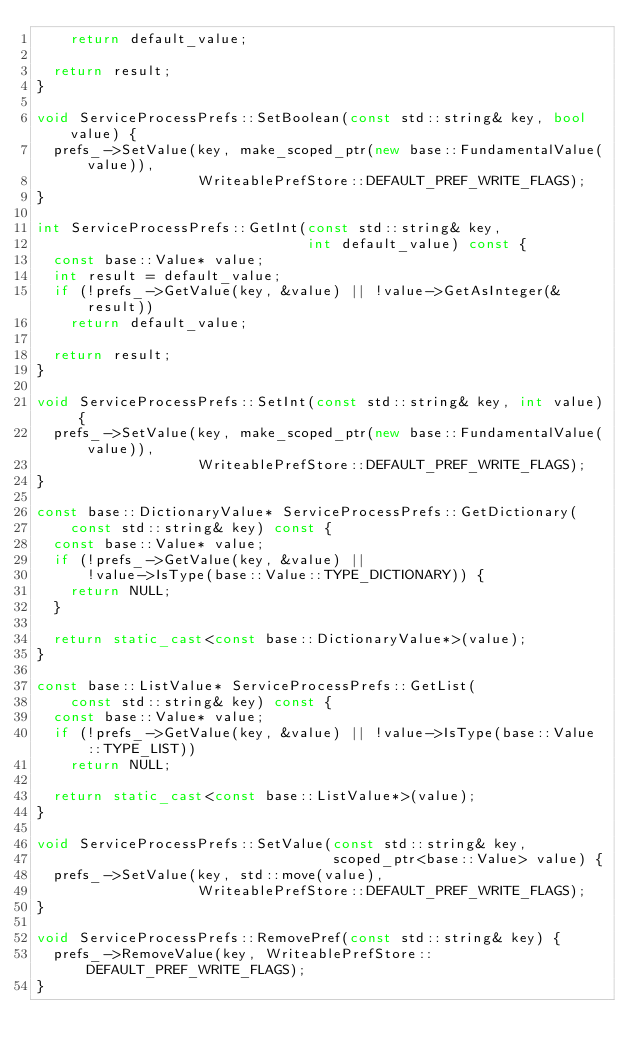Convert code to text. <code><loc_0><loc_0><loc_500><loc_500><_C++_>    return default_value;

  return result;
}

void ServiceProcessPrefs::SetBoolean(const std::string& key, bool value) {
  prefs_->SetValue(key, make_scoped_ptr(new base::FundamentalValue(value)),
                   WriteablePrefStore::DEFAULT_PREF_WRITE_FLAGS);
}

int ServiceProcessPrefs::GetInt(const std::string& key,
                                int default_value) const {
  const base::Value* value;
  int result = default_value;
  if (!prefs_->GetValue(key, &value) || !value->GetAsInteger(&result))
    return default_value;

  return result;
}

void ServiceProcessPrefs::SetInt(const std::string& key, int value) {
  prefs_->SetValue(key, make_scoped_ptr(new base::FundamentalValue(value)),
                   WriteablePrefStore::DEFAULT_PREF_WRITE_FLAGS);
}

const base::DictionaryValue* ServiceProcessPrefs::GetDictionary(
    const std::string& key) const {
  const base::Value* value;
  if (!prefs_->GetValue(key, &value) ||
      !value->IsType(base::Value::TYPE_DICTIONARY)) {
    return NULL;
  }

  return static_cast<const base::DictionaryValue*>(value);
}

const base::ListValue* ServiceProcessPrefs::GetList(
    const std::string& key) const {
  const base::Value* value;
  if (!prefs_->GetValue(key, &value) || !value->IsType(base::Value::TYPE_LIST))
    return NULL;

  return static_cast<const base::ListValue*>(value);
}

void ServiceProcessPrefs::SetValue(const std::string& key,
                                   scoped_ptr<base::Value> value) {
  prefs_->SetValue(key, std::move(value),
                   WriteablePrefStore::DEFAULT_PREF_WRITE_FLAGS);
}

void ServiceProcessPrefs::RemovePref(const std::string& key) {
  prefs_->RemoveValue(key, WriteablePrefStore::DEFAULT_PREF_WRITE_FLAGS);
}

</code> 